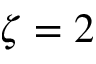Convert formula to latex. <formula><loc_0><loc_0><loc_500><loc_500>\zeta = 2</formula> 